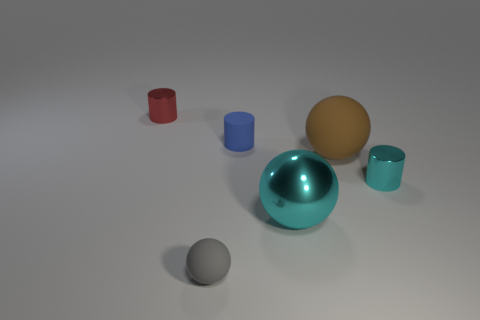Which object stands out the most in this image and why? The large teal metallic sphere stands out the most due to its size, reflective surface, and the vibrant contrast of its color against the more muted tones of the other objects and background. 